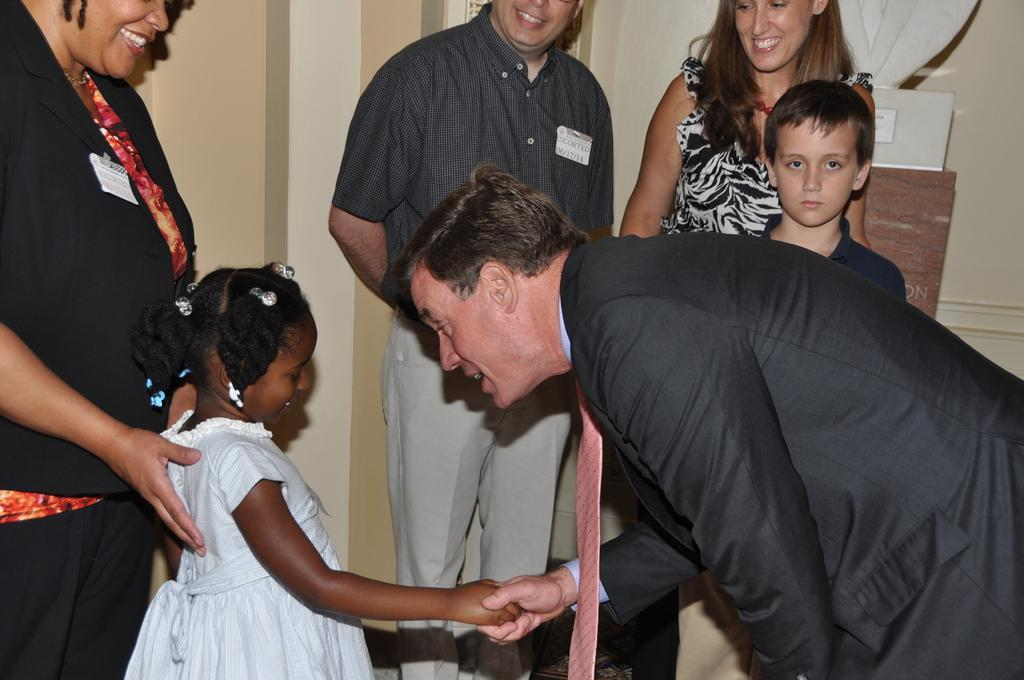Who or what can be seen in the image? There are people in the image. What is visible in the background of the image? There is a wall in the background of the image. Can you describe the object placed on a stand in the image? Unfortunately, the facts provided do not give enough information to describe the object placed on a stand. What month is it in the image? The facts provided do not give any information about the month or time of year, so it cannot be determined from the image. 